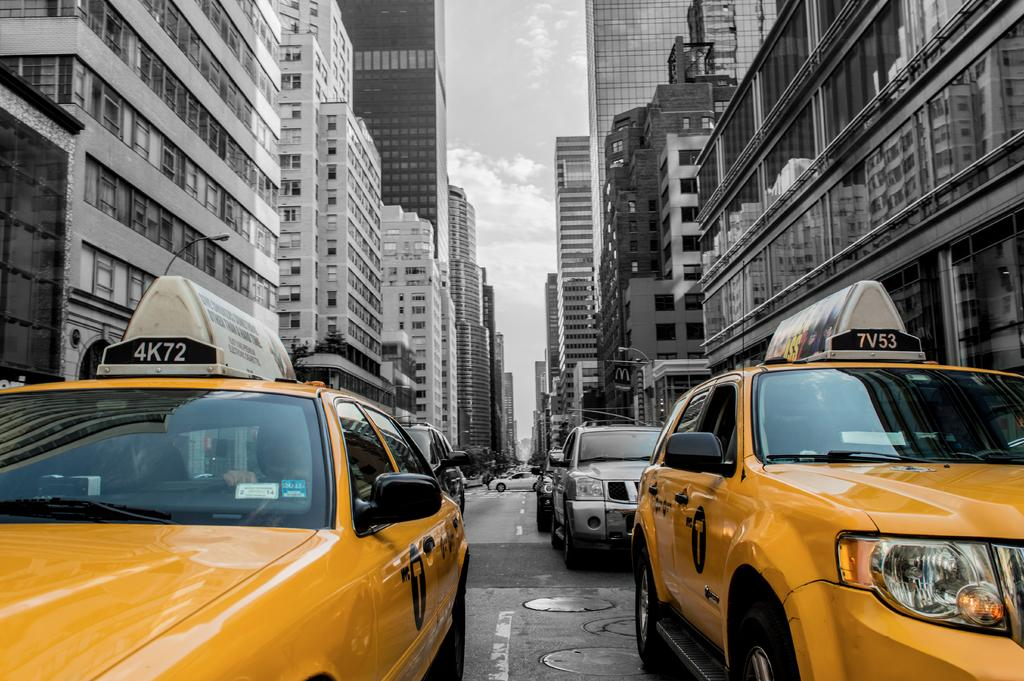What can be seen on the road in the image? There are cars on the road in the image. What is visible in the background of the image? There are buildings and poles in the background of the image. What part of the natural environment is visible in the image? The sky is visible in the background of the image. How much salt is sprinkled on the cars in the image? There is no salt present in the image; it features cars on the road. What type of chin can be seen on the buildings in the image? There is no chin present in the image; it features buildings in the background. 